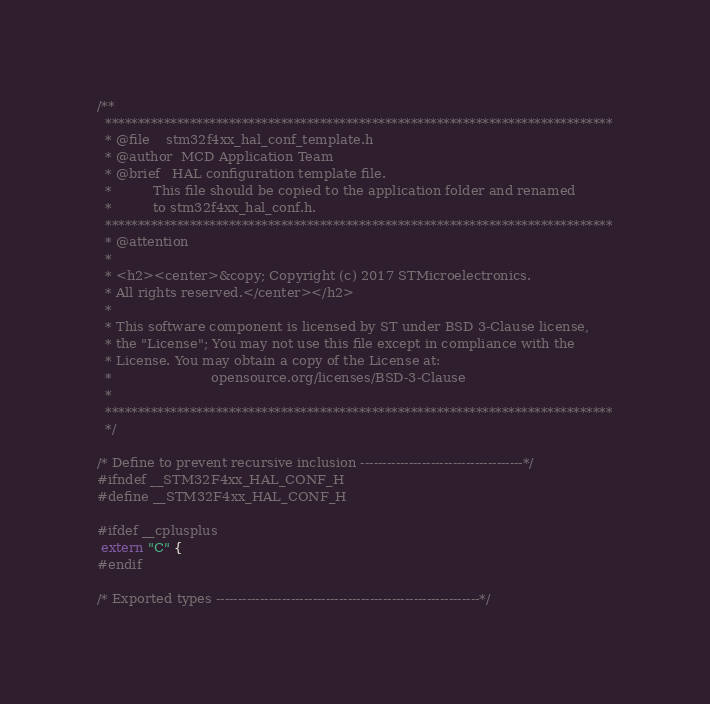<code> <loc_0><loc_0><loc_500><loc_500><_C_>/**
  ******************************************************************************
  * @file    stm32f4xx_hal_conf_template.h
  * @author  MCD Application Team
  * @brief   HAL configuration template file.
  *          This file should be copied to the application folder and renamed
  *          to stm32f4xx_hal_conf.h.
  ******************************************************************************
  * @attention
  *
  * <h2><center>&copy; Copyright (c) 2017 STMicroelectronics.
  * All rights reserved.</center></h2>
  *
  * This software component is licensed by ST under BSD 3-Clause license,
  * the "License"; You may not use this file except in compliance with the
  * License. You may obtain a copy of the License at:
  *                        opensource.org/licenses/BSD-3-Clause
  *
  ******************************************************************************
  */

/* Define to prevent recursive inclusion -------------------------------------*/
#ifndef __STM32F4xx_HAL_CONF_H
#define __STM32F4xx_HAL_CONF_H

#ifdef __cplusplus
 extern "C" {
#endif

/* Exported types ------------------------------------------------------------*/</code> 